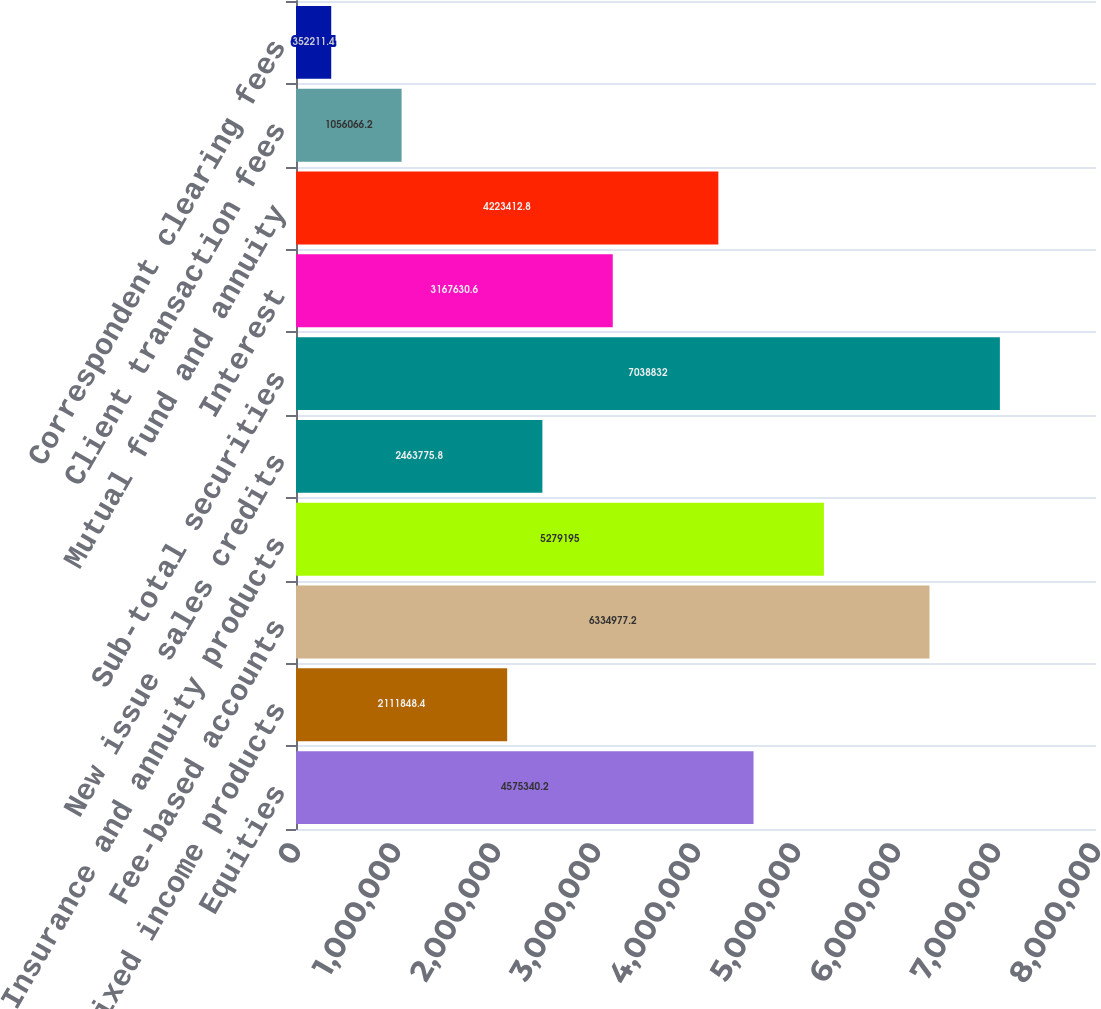Convert chart to OTSL. <chart><loc_0><loc_0><loc_500><loc_500><bar_chart><fcel>Equities<fcel>Fixed income products<fcel>Fee-based accounts<fcel>Insurance and annuity products<fcel>New issue sales credits<fcel>Sub-total securities<fcel>Interest<fcel>Mutual fund and annuity<fcel>Client transaction fees<fcel>Correspondent clearing fees<nl><fcel>4.57534e+06<fcel>2.11185e+06<fcel>6.33498e+06<fcel>5.2792e+06<fcel>2.46378e+06<fcel>7.03883e+06<fcel>3.16763e+06<fcel>4.22341e+06<fcel>1.05607e+06<fcel>352211<nl></chart> 